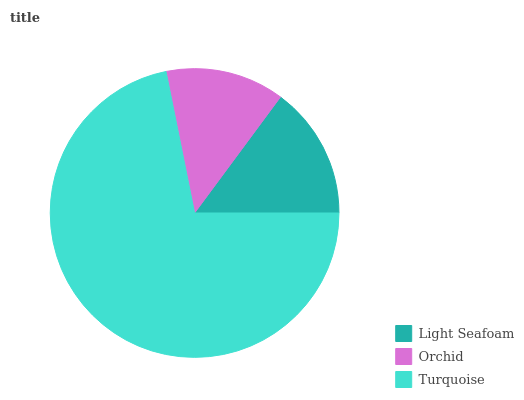Is Orchid the minimum?
Answer yes or no. Yes. Is Turquoise the maximum?
Answer yes or no. Yes. Is Turquoise the minimum?
Answer yes or no. No. Is Orchid the maximum?
Answer yes or no. No. Is Turquoise greater than Orchid?
Answer yes or no. Yes. Is Orchid less than Turquoise?
Answer yes or no. Yes. Is Orchid greater than Turquoise?
Answer yes or no. No. Is Turquoise less than Orchid?
Answer yes or no. No. Is Light Seafoam the high median?
Answer yes or no. Yes. Is Light Seafoam the low median?
Answer yes or no. Yes. Is Turquoise the high median?
Answer yes or no. No. Is Orchid the low median?
Answer yes or no. No. 